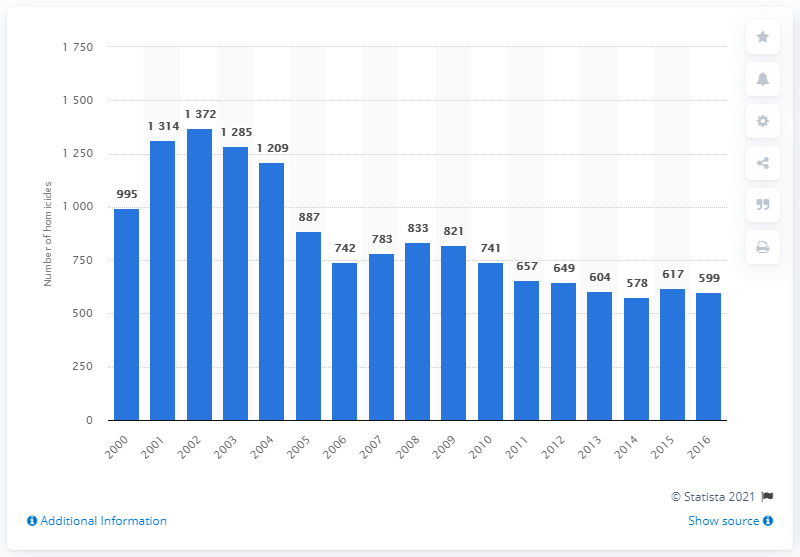Draw attention to some important aspects in this diagram. There were 617 homicides in Paraguay in 2016. In 2016, a total of 599 individuals were murdered in Paraguay. 